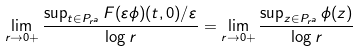Convert formula to latex. <formula><loc_0><loc_0><loc_500><loc_500>\lim _ { r \to 0 + } \frac { \sup _ { t \in P _ { r ^ { a } } } F ( \varepsilon \phi ) ( t , 0 ) / \varepsilon } { \log r } = \lim _ { r \to 0 + } \frac { \sup _ { z \in P _ { r ^ { a } } } \phi ( z ) } { \log r }</formula> 